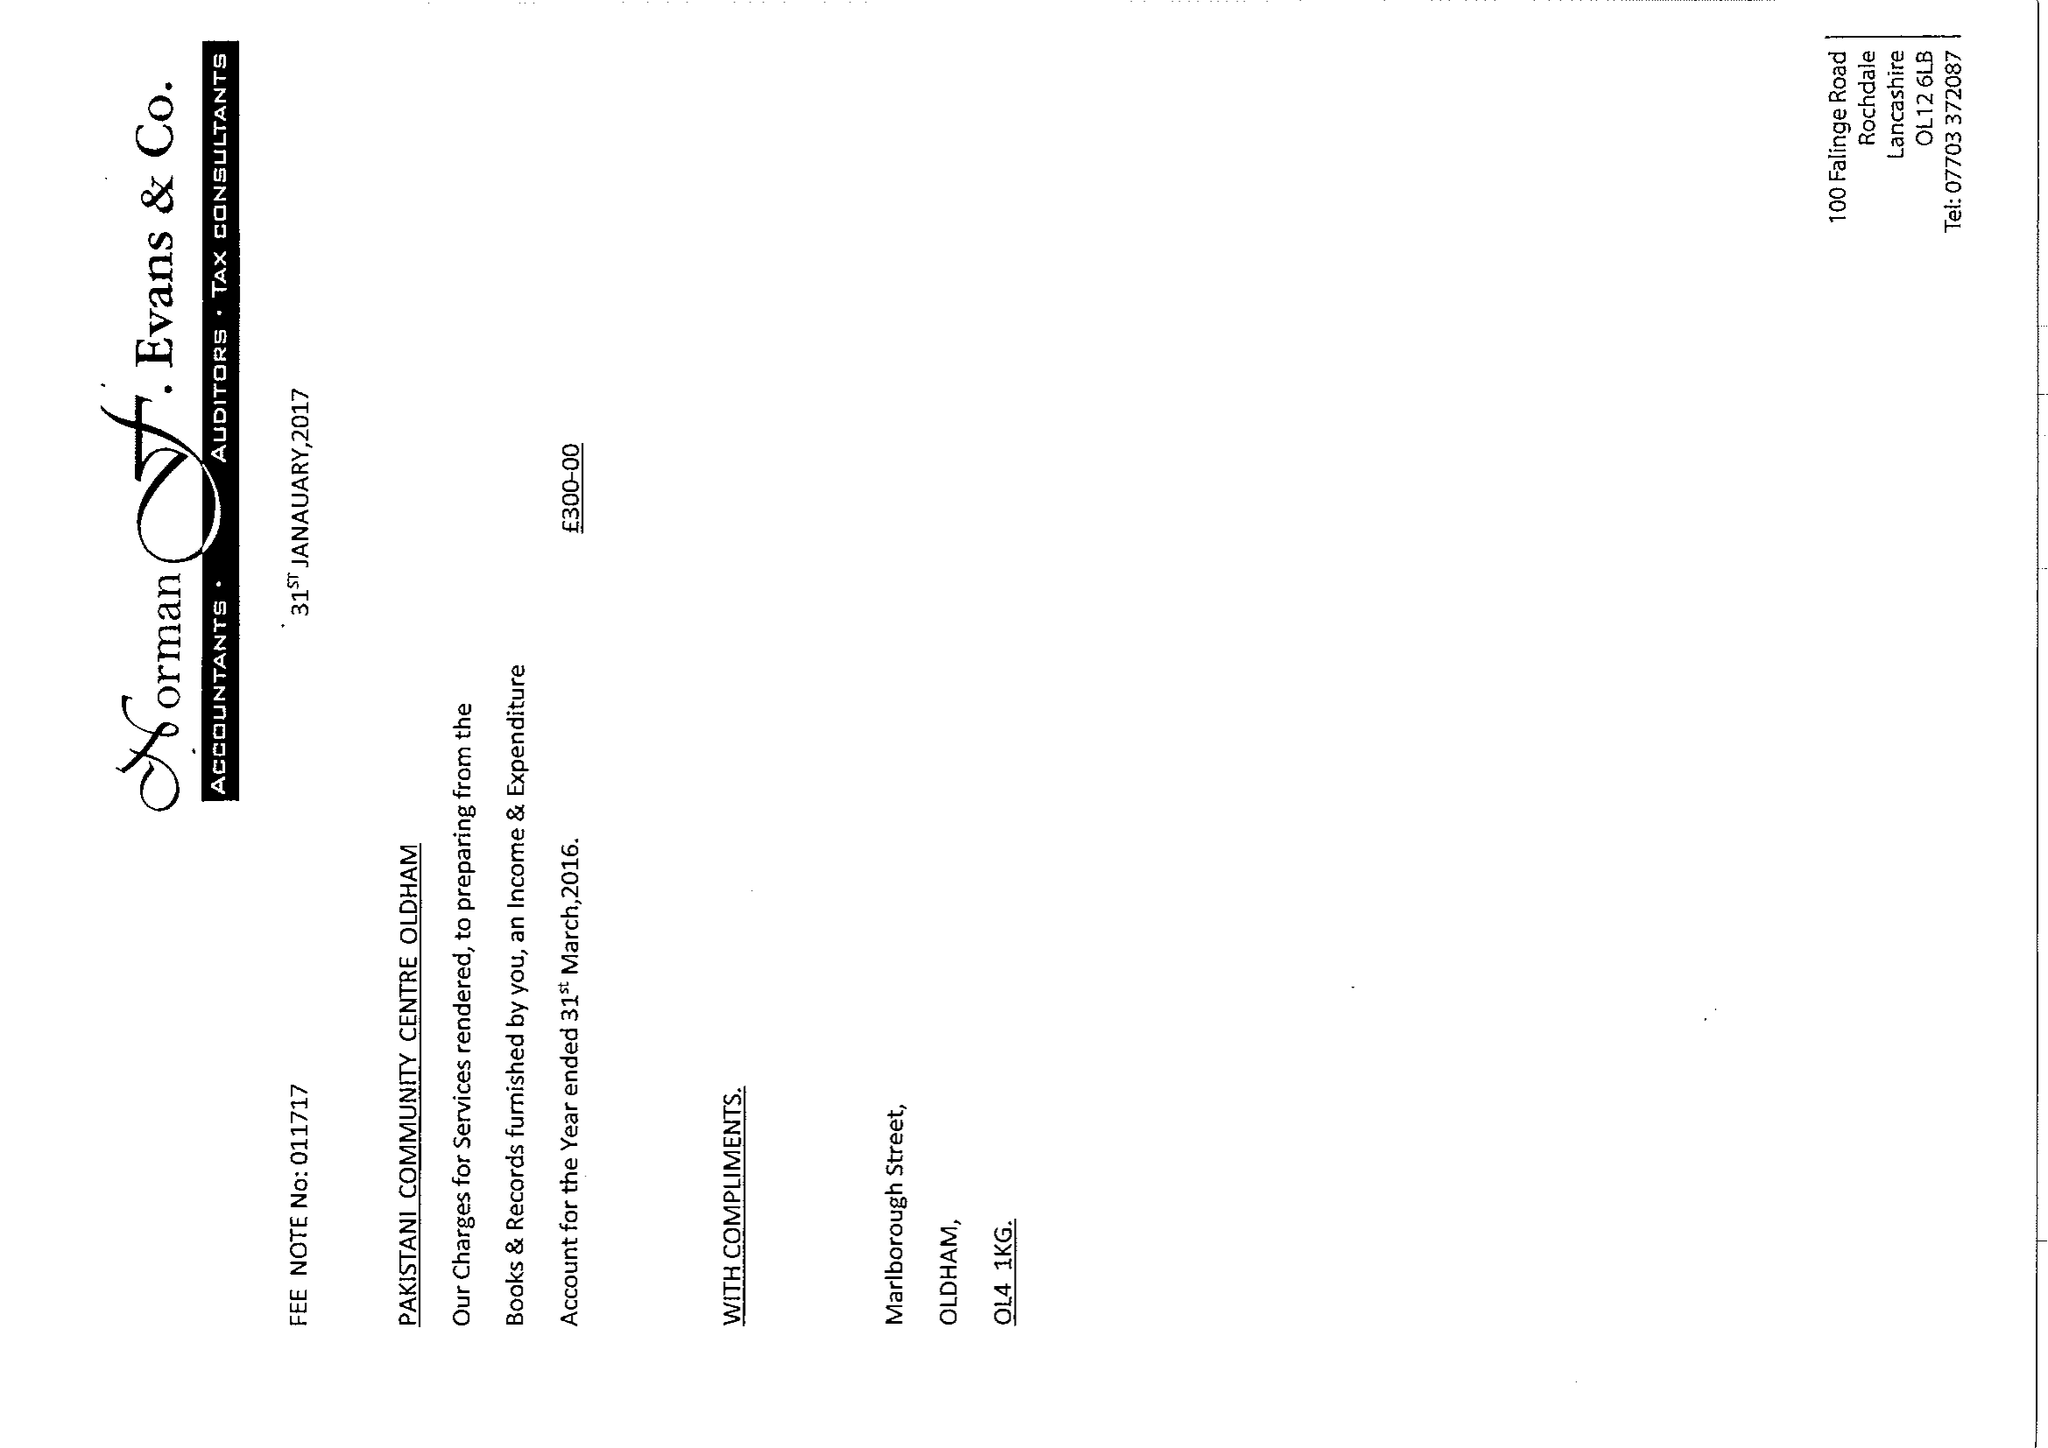What is the value for the charity_name?
Answer the question using a single word or phrase. Pakistani Community Centre, Oldham 